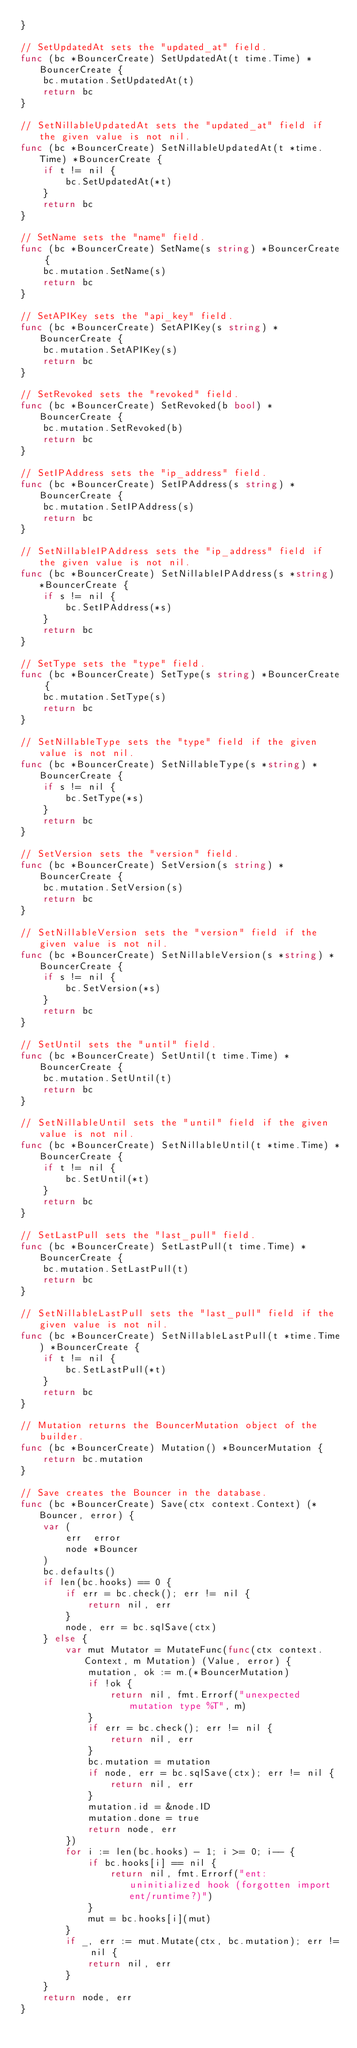Convert code to text. <code><loc_0><loc_0><loc_500><loc_500><_Go_>}

// SetUpdatedAt sets the "updated_at" field.
func (bc *BouncerCreate) SetUpdatedAt(t time.Time) *BouncerCreate {
	bc.mutation.SetUpdatedAt(t)
	return bc
}

// SetNillableUpdatedAt sets the "updated_at" field if the given value is not nil.
func (bc *BouncerCreate) SetNillableUpdatedAt(t *time.Time) *BouncerCreate {
	if t != nil {
		bc.SetUpdatedAt(*t)
	}
	return bc
}

// SetName sets the "name" field.
func (bc *BouncerCreate) SetName(s string) *BouncerCreate {
	bc.mutation.SetName(s)
	return bc
}

// SetAPIKey sets the "api_key" field.
func (bc *BouncerCreate) SetAPIKey(s string) *BouncerCreate {
	bc.mutation.SetAPIKey(s)
	return bc
}

// SetRevoked sets the "revoked" field.
func (bc *BouncerCreate) SetRevoked(b bool) *BouncerCreate {
	bc.mutation.SetRevoked(b)
	return bc
}

// SetIPAddress sets the "ip_address" field.
func (bc *BouncerCreate) SetIPAddress(s string) *BouncerCreate {
	bc.mutation.SetIPAddress(s)
	return bc
}

// SetNillableIPAddress sets the "ip_address" field if the given value is not nil.
func (bc *BouncerCreate) SetNillableIPAddress(s *string) *BouncerCreate {
	if s != nil {
		bc.SetIPAddress(*s)
	}
	return bc
}

// SetType sets the "type" field.
func (bc *BouncerCreate) SetType(s string) *BouncerCreate {
	bc.mutation.SetType(s)
	return bc
}

// SetNillableType sets the "type" field if the given value is not nil.
func (bc *BouncerCreate) SetNillableType(s *string) *BouncerCreate {
	if s != nil {
		bc.SetType(*s)
	}
	return bc
}

// SetVersion sets the "version" field.
func (bc *BouncerCreate) SetVersion(s string) *BouncerCreate {
	bc.mutation.SetVersion(s)
	return bc
}

// SetNillableVersion sets the "version" field if the given value is not nil.
func (bc *BouncerCreate) SetNillableVersion(s *string) *BouncerCreate {
	if s != nil {
		bc.SetVersion(*s)
	}
	return bc
}

// SetUntil sets the "until" field.
func (bc *BouncerCreate) SetUntil(t time.Time) *BouncerCreate {
	bc.mutation.SetUntil(t)
	return bc
}

// SetNillableUntil sets the "until" field if the given value is not nil.
func (bc *BouncerCreate) SetNillableUntil(t *time.Time) *BouncerCreate {
	if t != nil {
		bc.SetUntil(*t)
	}
	return bc
}

// SetLastPull sets the "last_pull" field.
func (bc *BouncerCreate) SetLastPull(t time.Time) *BouncerCreate {
	bc.mutation.SetLastPull(t)
	return bc
}

// SetNillableLastPull sets the "last_pull" field if the given value is not nil.
func (bc *BouncerCreate) SetNillableLastPull(t *time.Time) *BouncerCreate {
	if t != nil {
		bc.SetLastPull(*t)
	}
	return bc
}

// Mutation returns the BouncerMutation object of the builder.
func (bc *BouncerCreate) Mutation() *BouncerMutation {
	return bc.mutation
}

// Save creates the Bouncer in the database.
func (bc *BouncerCreate) Save(ctx context.Context) (*Bouncer, error) {
	var (
		err  error
		node *Bouncer
	)
	bc.defaults()
	if len(bc.hooks) == 0 {
		if err = bc.check(); err != nil {
			return nil, err
		}
		node, err = bc.sqlSave(ctx)
	} else {
		var mut Mutator = MutateFunc(func(ctx context.Context, m Mutation) (Value, error) {
			mutation, ok := m.(*BouncerMutation)
			if !ok {
				return nil, fmt.Errorf("unexpected mutation type %T", m)
			}
			if err = bc.check(); err != nil {
				return nil, err
			}
			bc.mutation = mutation
			if node, err = bc.sqlSave(ctx); err != nil {
				return nil, err
			}
			mutation.id = &node.ID
			mutation.done = true
			return node, err
		})
		for i := len(bc.hooks) - 1; i >= 0; i-- {
			if bc.hooks[i] == nil {
				return nil, fmt.Errorf("ent: uninitialized hook (forgotten import ent/runtime?)")
			}
			mut = bc.hooks[i](mut)
		}
		if _, err := mut.Mutate(ctx, bc.mutation); err != nil {
			return nil, err
		}
	}
	return node, err
}
</code> 